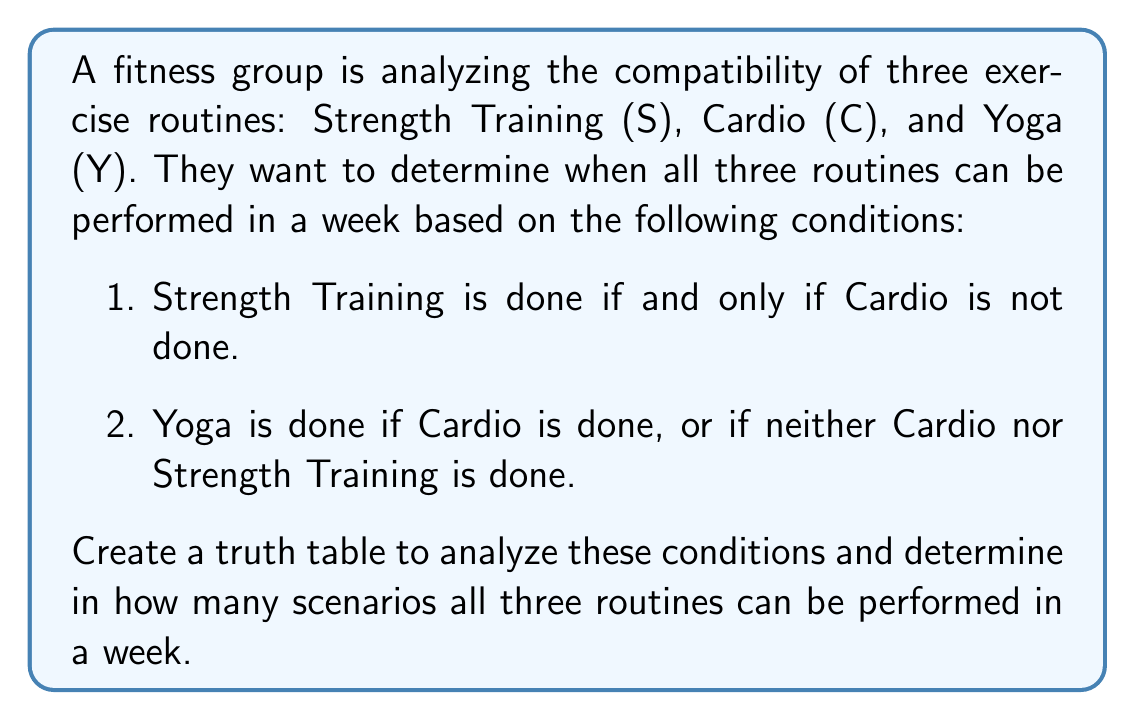Can you solve this math problem? Let's approach this step-by-step:

1) First, we need to create a truth table with all possible combinations of S, C, and Y. There are 2³ = 8 possible combinations.

2) Next, we'll evaluate the conditions:
   a) S ↔ ¬C (Strength Training if and only if not Cardio)
   b) Y ↔ C ∨ (¬C ∧ ¬S) (Yoga if Cardio or neither Cardio nor Strength Training)

3) Let's create the truth table:

   $$\begin{array}{|c|c|c|c|c|}
   \hline
   S & C & Y & S \leftrightarrow \neg C & Y \leftrightarrow C \lor (\neg C \land \neg S) \\
   \hline
   0 & 0 & 0 & 1 & 0 \\
   0 & 0 & 1 & 1 & 1 \\
   0 & 1 & 0 & 1 & 0 \\
   0 & 1 & 1 & 1 & 1 \\
   1 & 0 & 0 & 1 & 0 \\
   1 & 0 & 1 & 1 & 0 \\
   1 & 1 & 0 & 0 & 0 \\
   1 & 1 & 1 & 0 & 0 \\
   \hline
   \end{array}$$

4) For all three routines to be performed in a week, we need scenarios where both conditions are true (1) and all three variables (S, C, Y) have been true at least once.

5) From the truth table, we can see that there are two scenarios where both conditions are true:
   - S = 0, C = 0, Y = 1
   - S = 0, C = 1, Y = 1

6) However, we need S to be true at least once for all three routines to be performed. The scenario where this happens is:
   - S = 1, C = 0, Y = 0 (satisfies the first condition but not the second)

7) Therefore, to perform all three routines in a week while satisfying the given conditions, we need to combine these scenarios:
   - Do Strength Training on some days (S = 1, C = 0, Y = 0)
   - Do Cardio and Yoga on other days (S = 0, C = 1, Y = 1)

This combination satisfies both conditions and includes all three routines.
Answer: 1 scenario 